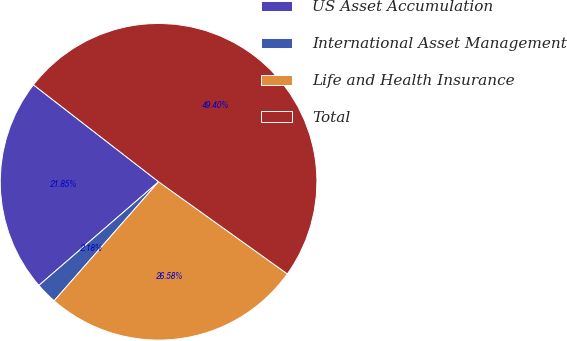Convert chart. <chart><loc_0><loc_0><loc_500><loc_500><pie_chart><fcel>US Asset Accumulation<fcel>International Asset Management<fcel>Life and Health Insurance<fcel>Total<nl><fcel>21.85%<fcel>2.18%<fcel>26.58%<fcel>49.4%<nl></chart> 